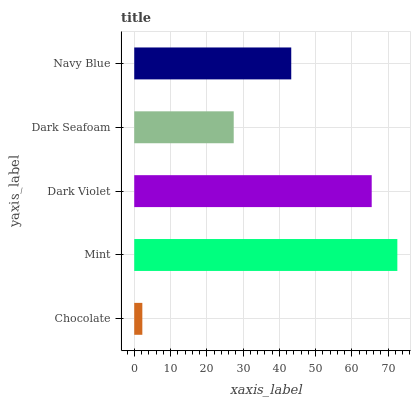Is Chocolate the minimum?
Answer yes or no. Yes. Is Mint the maximum?
Answer yes or no. Yes. Is Dark Violet the minimum?
Answer yes or no. No. Is Dark Violet the maximum?
Answer yes or no. No. Is Mint greater than Dark Violet?
Answer yes or no. Yes. Is Dark Violet less than Mint?
Answer yes or no. Yes. Is Dark Violet greater than Mint?
Answer yes or no. No. Is Mint less than Dark Violet?
Answer yes or no. No. Is Navy Blue the high median?
Answer yes or no. Yes. Is Navy Blue the low median?
Answer yes or no. Yes. Is Chocolate the high median?
Answer yes or no. No. Is Dark Violet the low median?
Answer yes or no. No. 